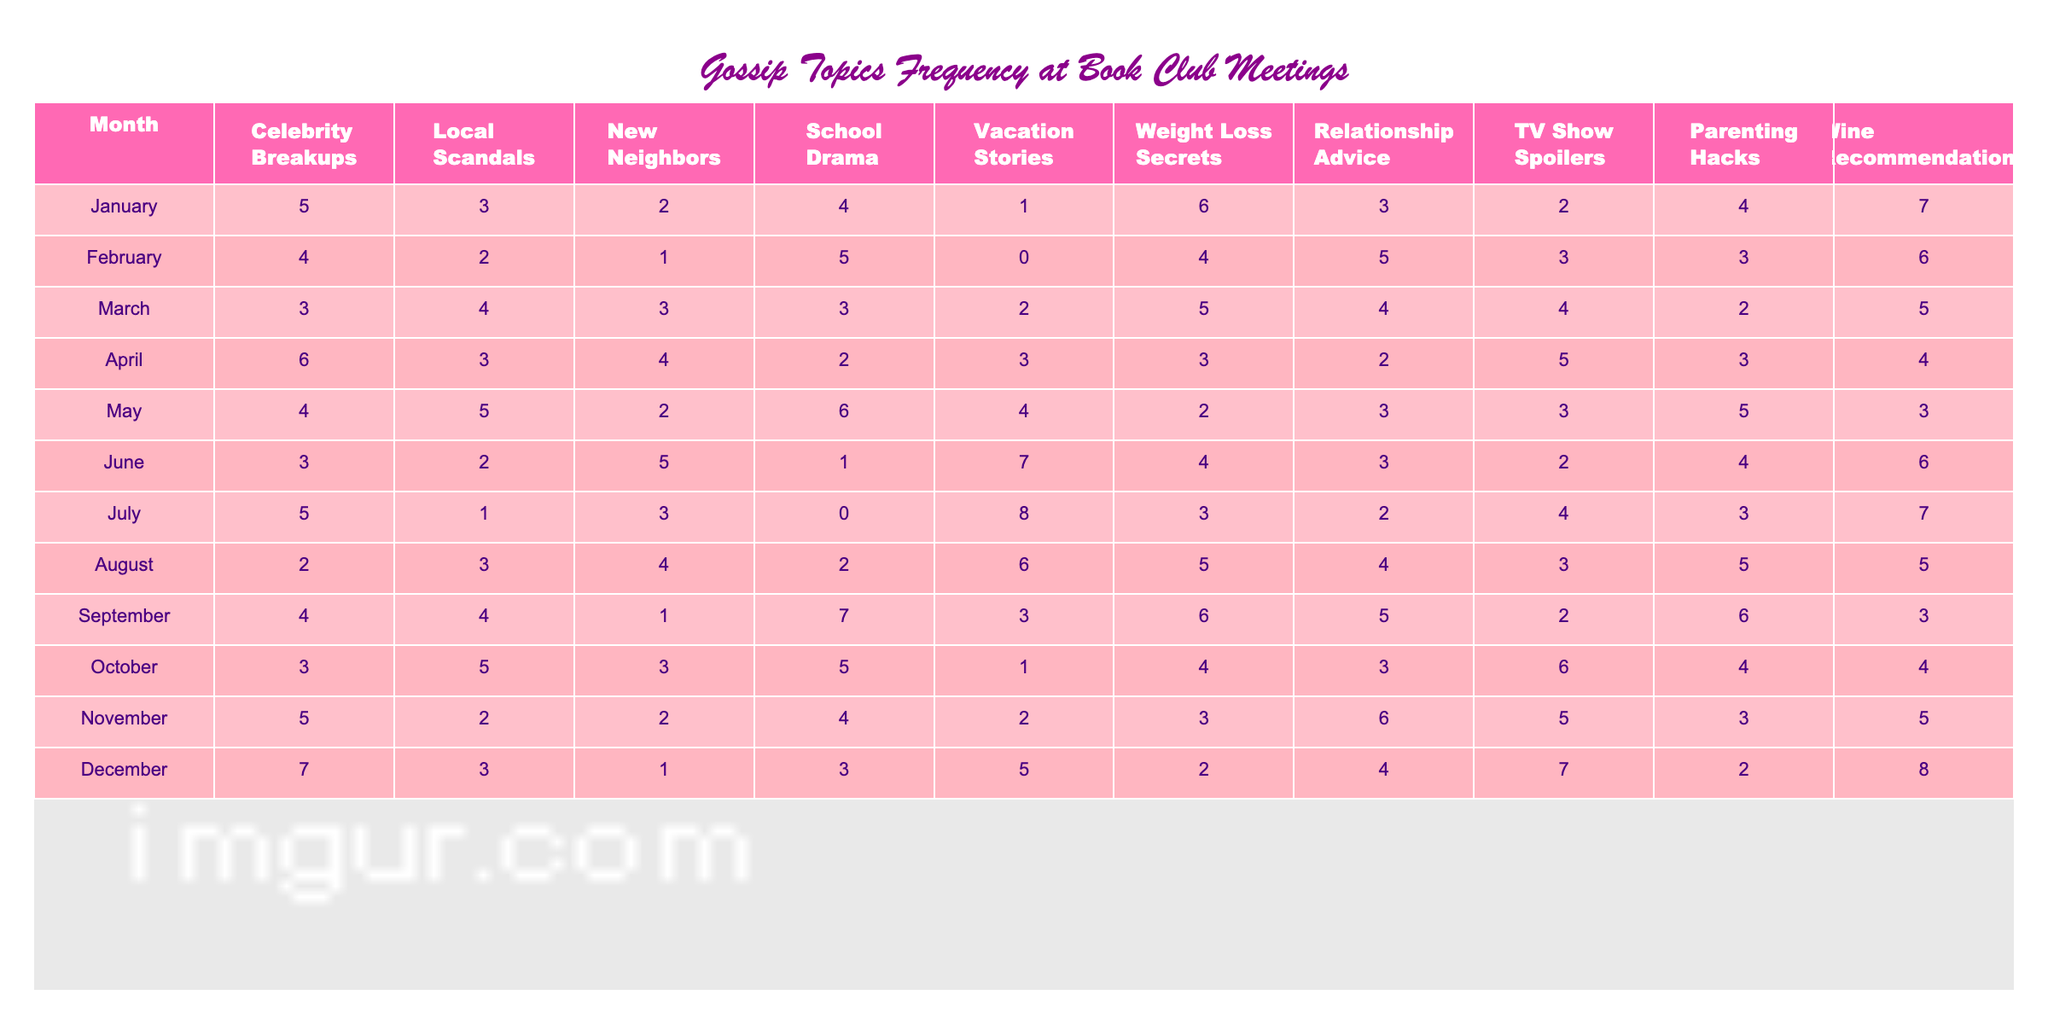What month had the highest number of 'Celebrity Breakups'? Looking at the data in the 'Celebrity Breakups' column, January has the highest value of 7.
Answer: January Which month had the least frequency of 'Local Scandals'? By scanning the 'Local Scandals' column, February has the lowest count of 2.
Answer: February What is the total number of 'New Neighbors' talked about over the months? Adding all values in the 'New Neighbors' column, the total is (2 + 1 + 3 + 4 + 2 + 5 + 3 + 4 + 1 + 3 + 2 + 1) = 33.
Answer: 33 In which month were the most 'Vacation Stories' shared? The column 'Vacation Stories' shows that July had the highest frequency with a value of 8.
Answer: July What is the average frequency of 'Weight Loss Secrets' from January to December? Summing the 'Weight Loss Secrets' values gives (6 + 4 + 5 + 3 + 2 + 4 + 3 + 5 + 6 + 4 + 3 + 2) = 57. Dividing by 12 months gives an average of 57/12 = 4.75.
Answer: 4.75 Is it true that 'TV Show Spoilers' were discussed more frequently in December than in October? In December, 'TV Show Spoilers' scored 7 while in October it was 6. Since 7 > 6, the statement is true.
Answer: True Which topic had the highest cumulative total across all months? To find the highest cumulative topic, add the totals for each topic: Celebrity Breakups (5+4+3+6+4+3+5+2+4+3+5+7)=57, Local Scandals (3+2+4+3+5+2+1+3+4+5+2+3)=37, New Neighbors (2+1+3+4+2+5+3+4+1+3+2+1)=33, School Drama (4+5+3+2+6+1+0+2+7+5+4+3)=43, Vacation Stories (1+0+2+3+4+7+8+6+3+1+2+5)=42, Weight Loss Secrets (6+4+5+3+2+4+3+5+6+4+3+2)=57, Relationship Advice (3+5+4+2+3+3+2+4+5+3+6+4)=52, TV Show Spoilers (2+3+4+5+3+2+4+3+2+6+5+7)=53, Parenting Hacks (4+3+2+3+5+4+3+5+6+4+3+2)=48, and Wine Recommendations (7+6+5+4+3+6+7+5+3+4+5+8)=63. Wine Recommendations has the highest total of 63.
Answer: Wine Recommendations What is the difference in counts for 'Parenting Hacks' between the month with the highest and lowest frequency? The highest frequency of 'Parenting Hacks' is in January (7) and the lowest is in June and February (2). The difference is 7 - 2 = 5.
Answer: 5 How many months showed a frequency of 'Relationship Advice' greater than 5? By examining the 'Relationship Advice' data, the months that show a frequency greater than 5 are February (5) and December (6), leading to a count of 1 month.
Answer: 1 